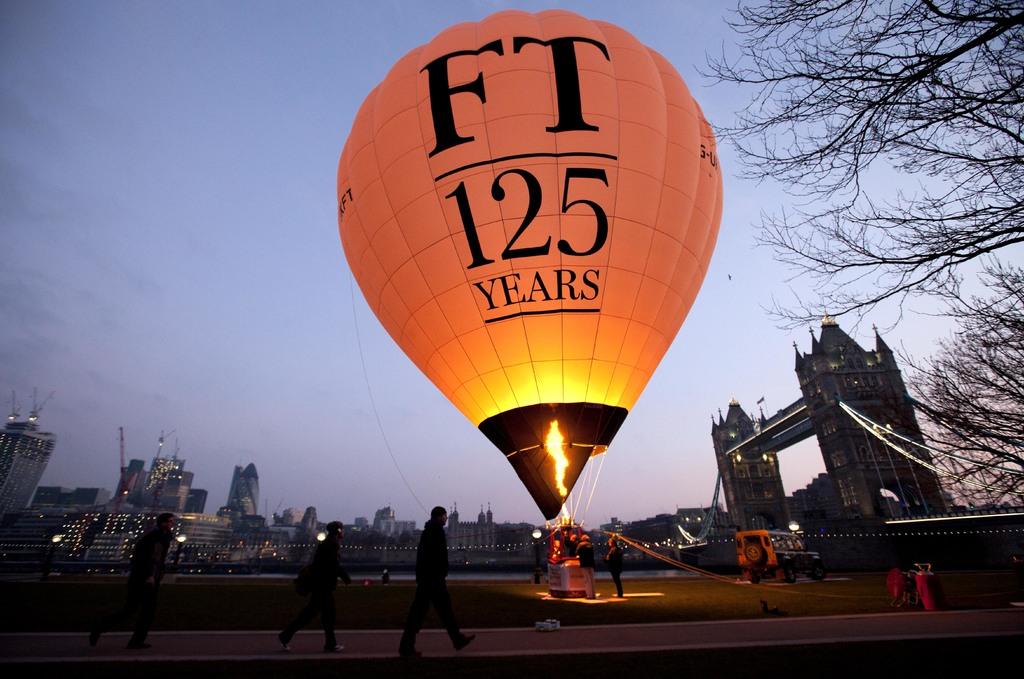How many years?
Give a very brief answer. 125. What are the two letters at the top?
Your response must be concise. Ft. 